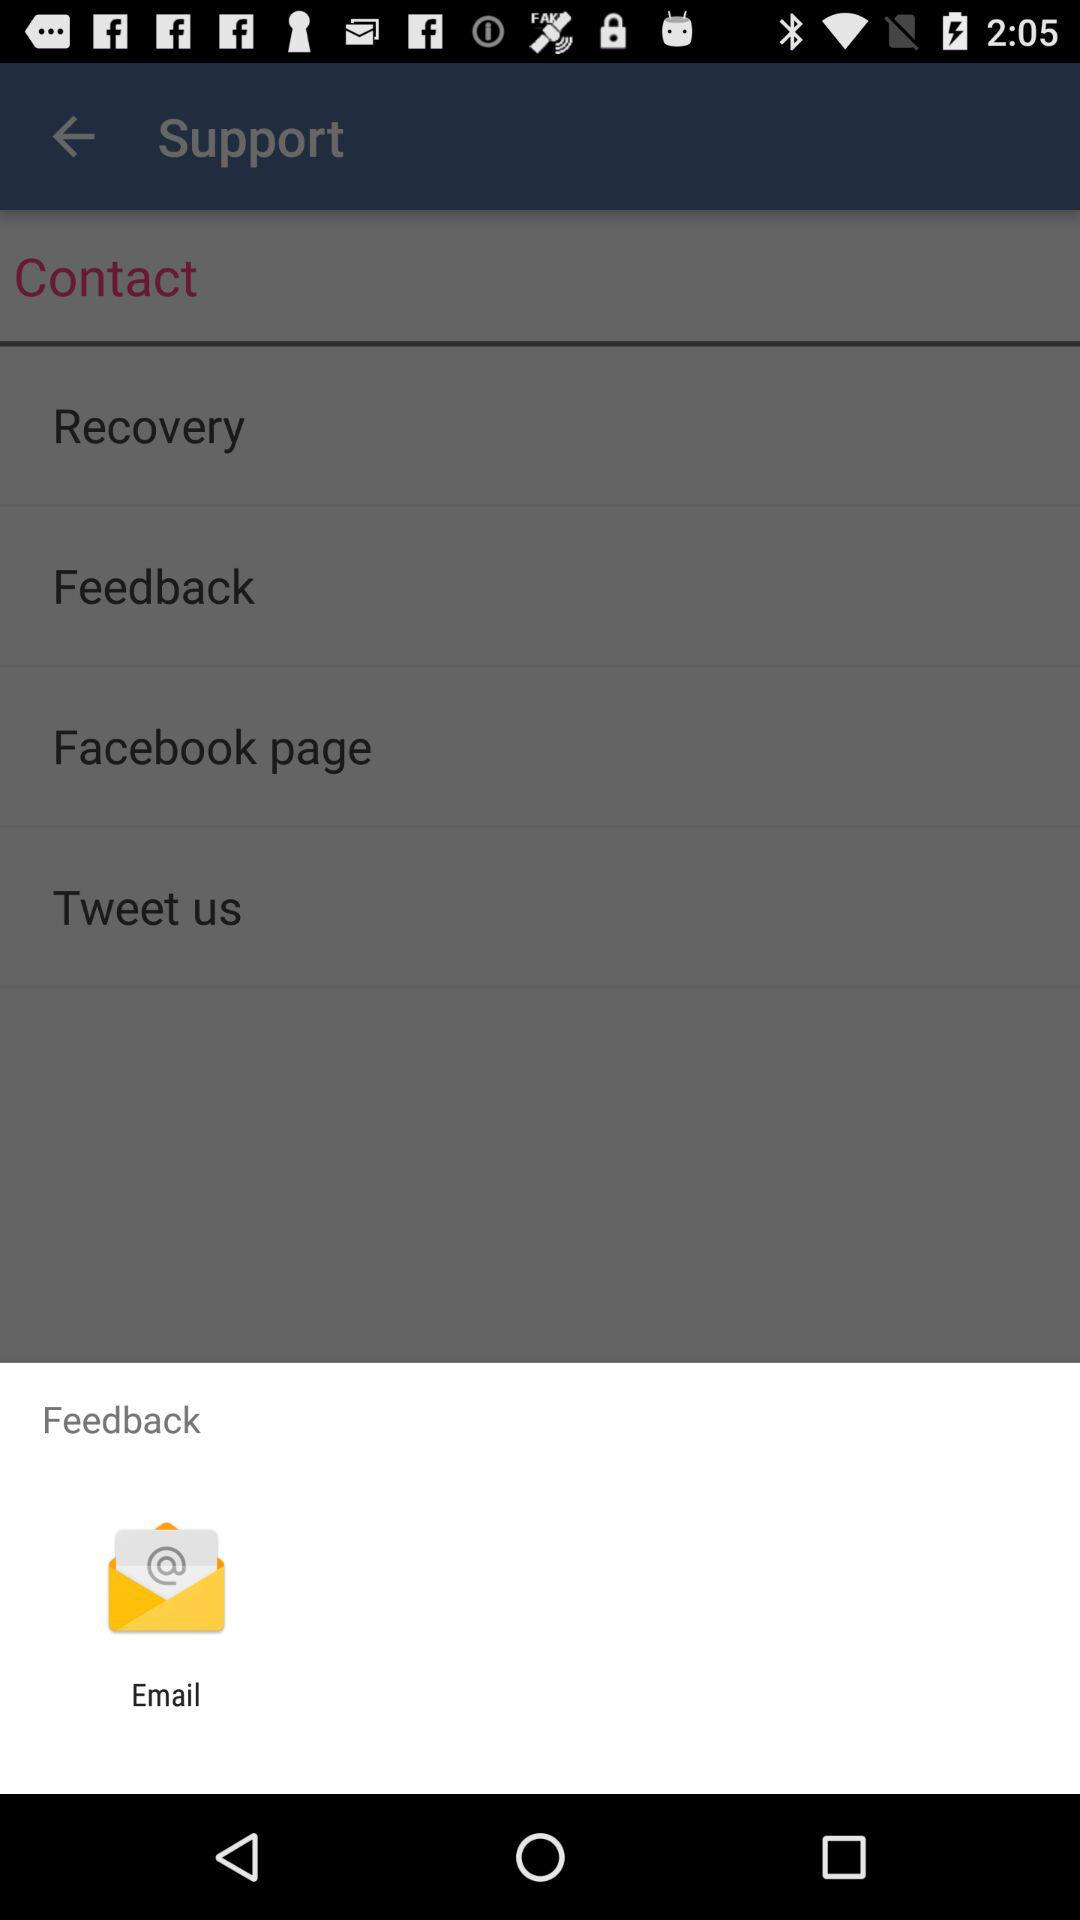Through what application can we share feedback? You can share feedback through "Email". 